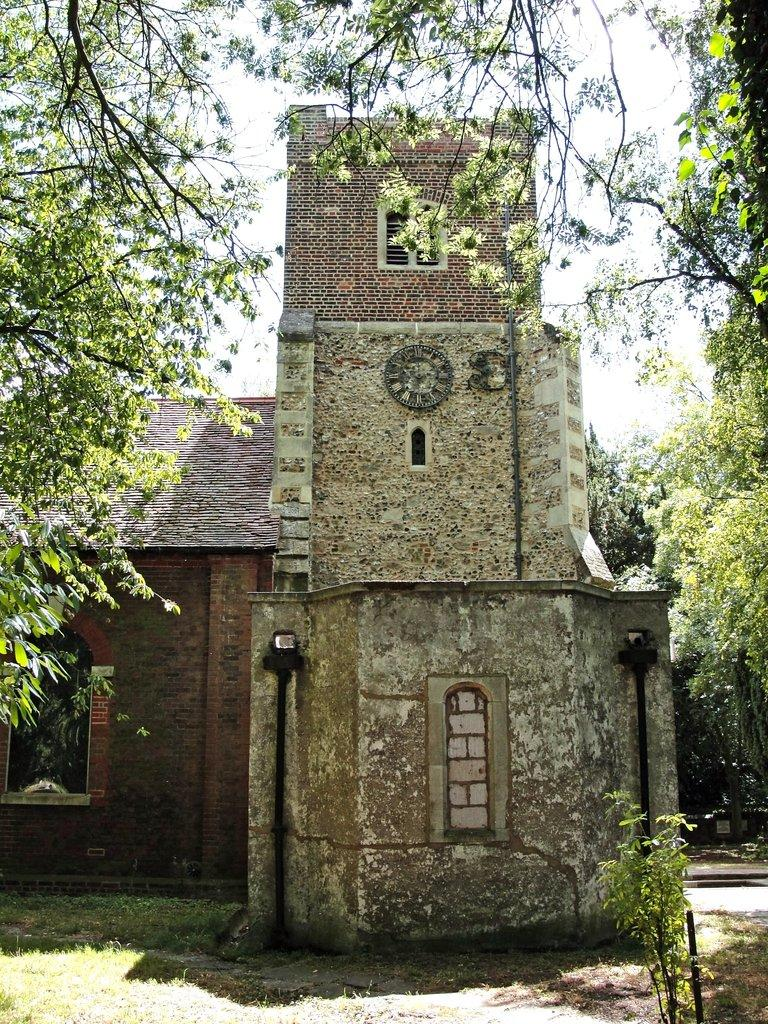What is the main structure in the center of the image? There is a building in the center of the image. What can be seen on the wall of the building? There is a clock on the wall of the building. What type of natural elements are visible in the background of the image? There are trees, poles, and plants in the background of the image. What is visible at the bottom of the image? There is ground visible at the bottom of the image. What channel are the friends watching in the image? There are no friends or television channel present in the image. What type of veil is draped over the building in the image? There is no veil present in the image; it features a building with a clock on the wall. 